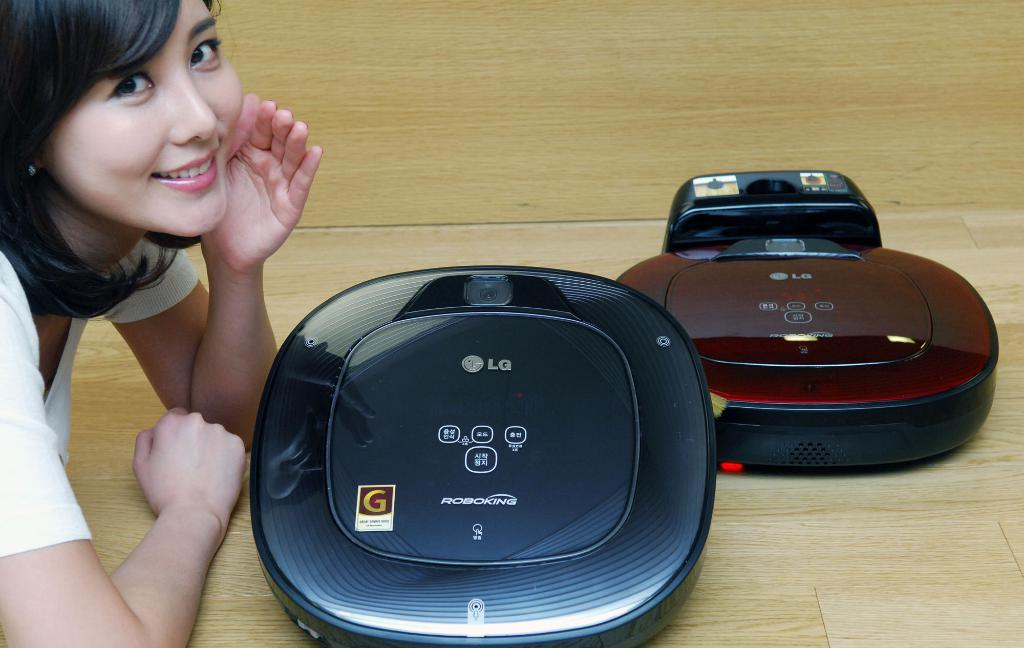<image>
Describe the image concisely. A woman lays on the floor in front of two LG Robo King Vacuums 